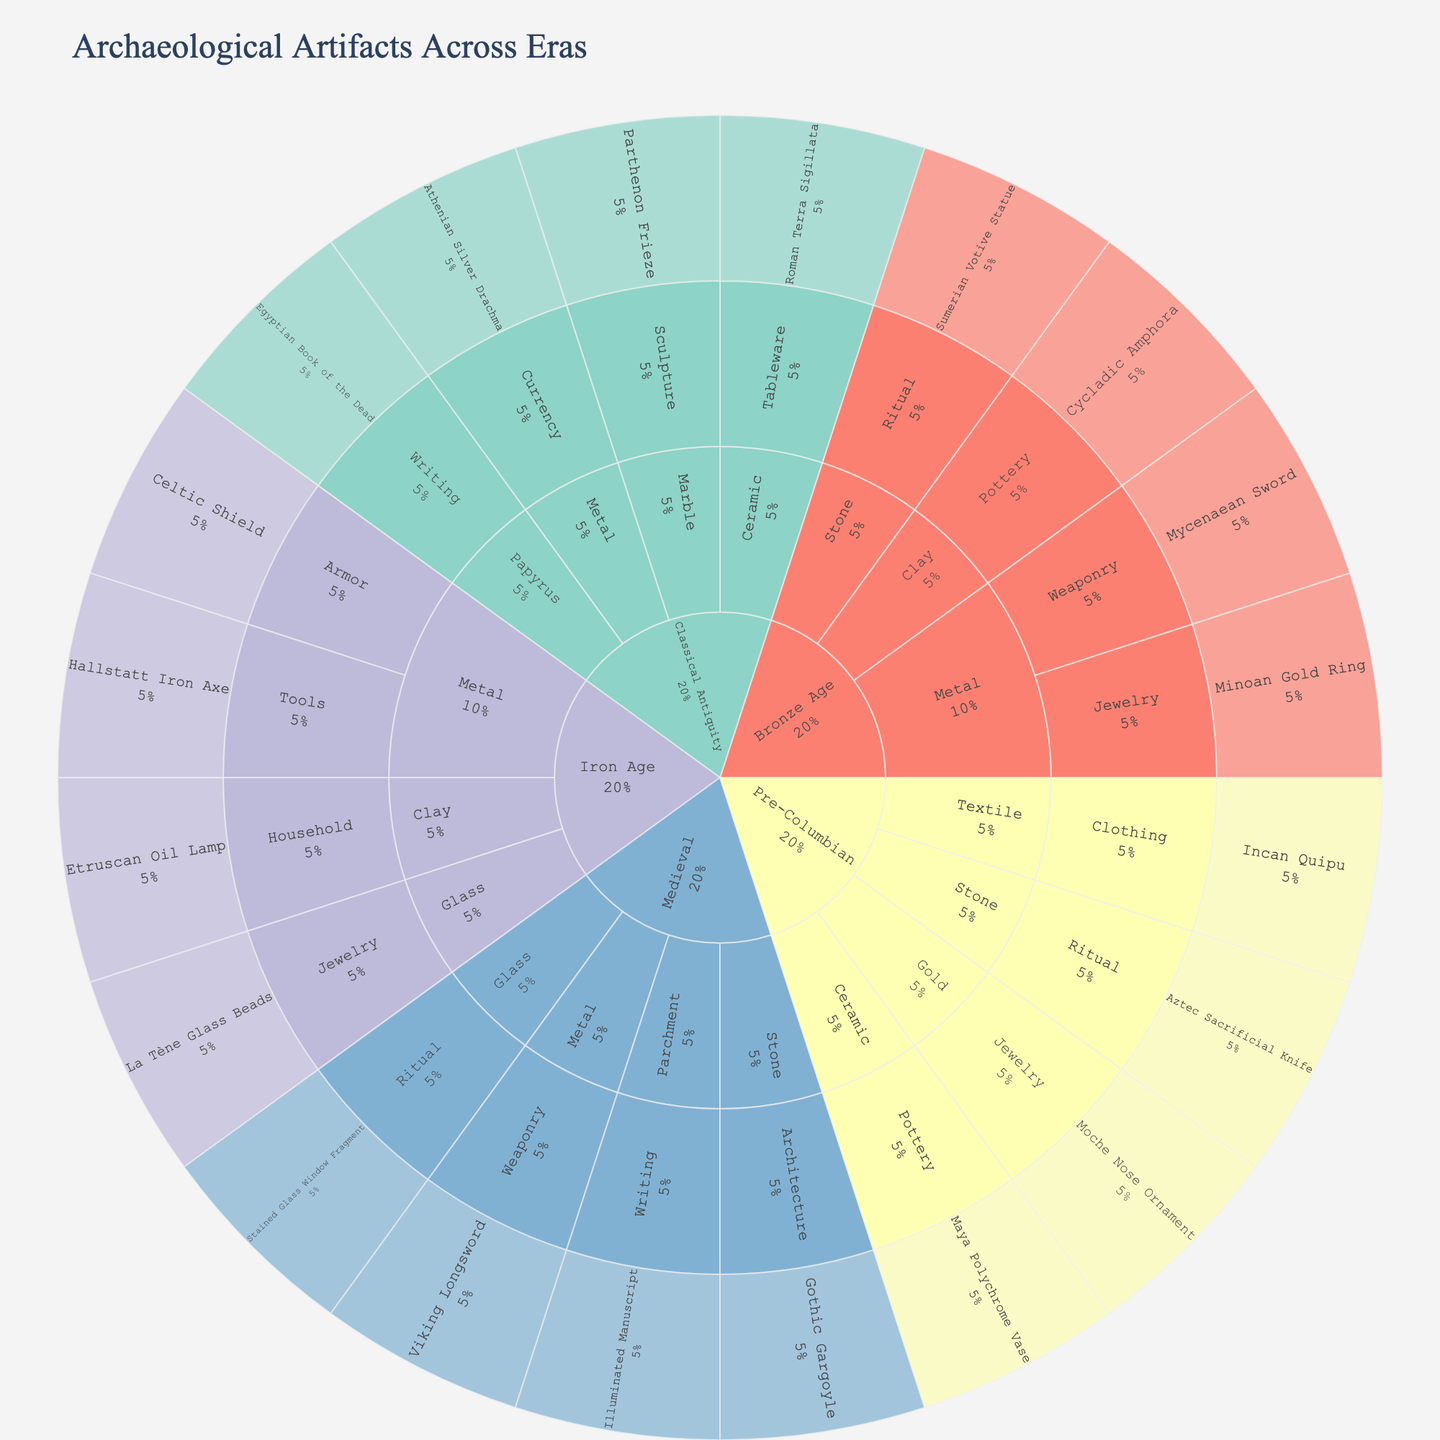What era has the most diverse range of materials for artifacts? Count the number of distinct materials linked to artifacts for each era. The era with the highest number of distinct materials is most diverse.
Answer: Classical Antiquity Which material category has the largest number of artifacts overall? Count the total number of artifacts for each material category across all eras. The material with the most artifacts is the one with the largest number.
Answer: Metal How many different artifacts are categorized under the Bronze Age? Sum the number of unique artifacts listed under "Bronze Age" in the plot.
Answer: Four Which artifact under the Iron Age is categorized as armor? Find the "Iron Age" era, then look under the "Metal" material category for the purpose "Armor". The artifact is listed under this category.
Answer: Celtic Shield Compare the number of Jewelry artifacts between the Bronze Age and Pre-Columbian eras. Which era has more? Count the number of artifacts categorized as "Jewelry" in both Bronze Age and Pre-Columbian eras and compare the two numbers.
Answer: Pre-Columbian What purpose does the Parthenon Frieze serve according to its categorization? Locate the "Parthenon Frieze" artifact and identify the corresponding purpose category it is listed under.
Answer: Sculpture Identify an artifact made from parchment and specify its purpose. Locate the artifact under the material "Parchment" and check its associated purpose category in the plot.
Answer: Illuminated Manuscript, Writing Is there a specific era where artifacts are categorized under tools? If so, name it. Search for the purpose category "Tools" and identify the era associated with it.
Answer: Iron Age Which era has artifacts made from the most materials, and what are these materials? Count the distinct materials for each era, and identify the era with the highest count along with listing those materials.
Answer: Classical Antiquity: Marble, Metal, Papyrus, Ceramic How are artifacts made from gold categorized by purpose? Locate the material "Gold" and list the purposes associated with the artifacts made from it.
Answer: Jewelry 